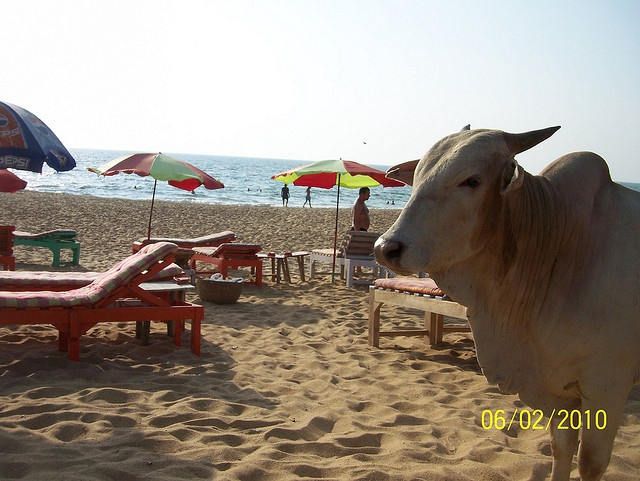Describe the objects in this image and their specific colors. I can see cow in white, black, maroon, and gray tones, chair in white, maroon, black, lightgray, and lightpink tones, chair in white, tan, maroon, and gray tones, umbrella in white, gray, navy, black, and maroon tones, and umbrella in white, brown, maroon, and khaki tones in this image. 